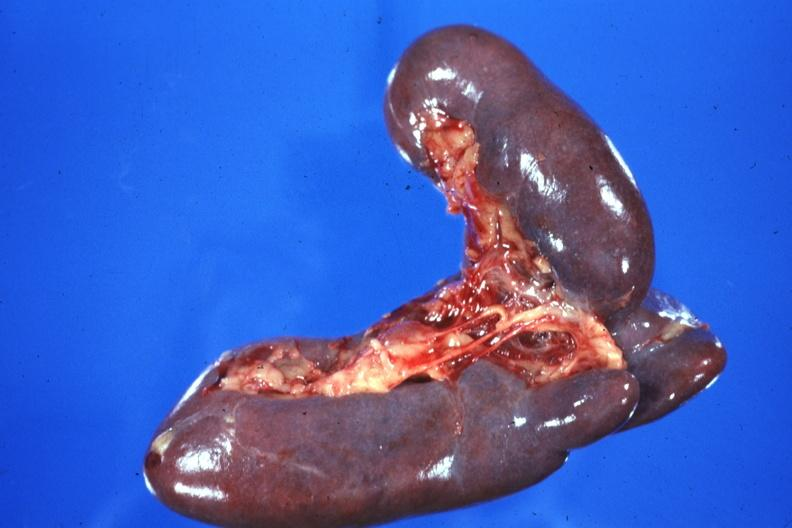s hematologic present?
Answer the question using a single word or phrase. Yes 